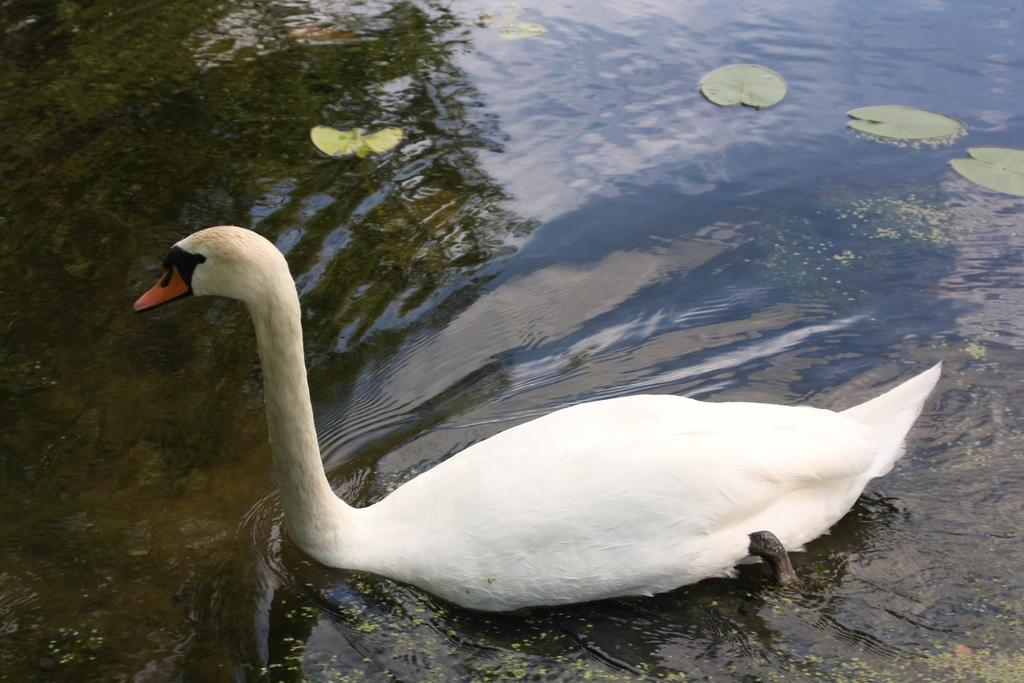What is the main subject in the center of the image? There is a swan in the center of the image. What can be seen in the background of the image? There is water and leaves visible in the background of the image. What type of ink is being used to draw the swan in the image? There is no indication that the swan is drawn or that ink is being used in the image. 